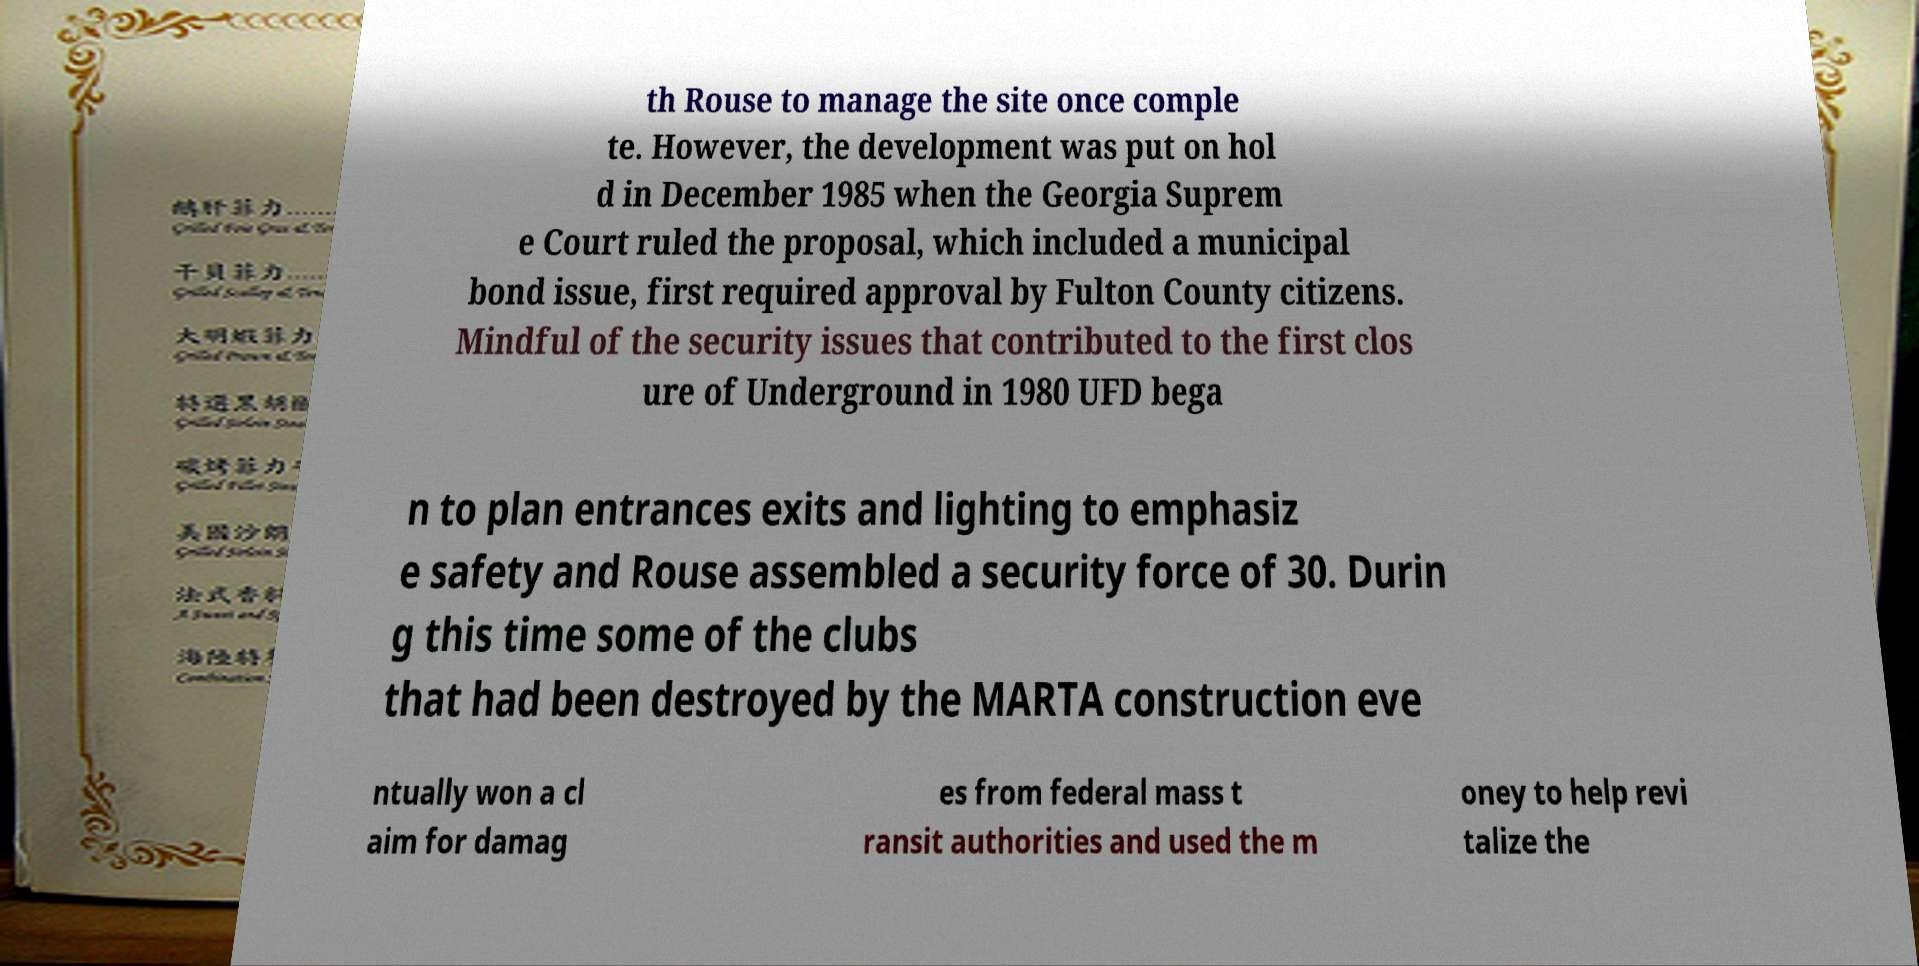What messages or text are displayed in this image? I need them in a readable, typed format. th Rouse to manage the site once comple te. However, the development was put on hol d in December 1985 when the Georgia Suprem e Court ruled the proposal, which included a municipal bond issue, first required approval by Fulton County citizens. Mindful of the security issues that contributed to the first clos ure of Underground in 1980 UFD bega n to plan entrances exits and lighting to emphasiz e safety and Rouse assembled a security force of 30. Durin g this time some of the clubs that had been destroyed by the MARTA construction eve ntually won a cl aim for damag es from federal mass t ransit authorities and used the m oney to help revi talize the 